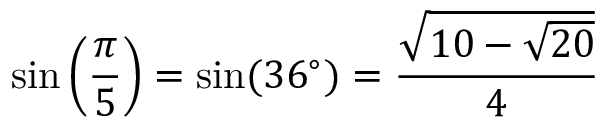Convert formula to latex. <formula><loc_0><loc_0><loc_500><loc_500>\sin \left ( { \frac { \pi } { 5 } } \right ) = \sin ( 3 6 ^ { \circ } ) = { \frac { \sqrt { 1 0 - { \sqrt { 2 0 } } } } { 4 } }</formula> 